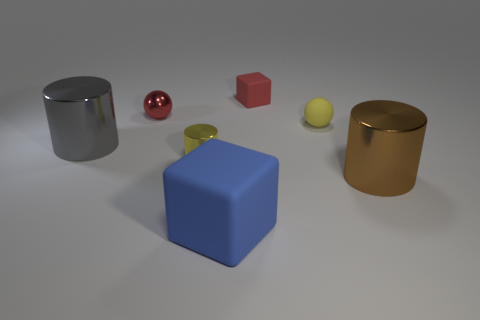Add 2 tiny yellow metal cylinders. How many objects exist? 9 Subtract all cylinders. How many objects are left? 4 Subtract all large gray objects. Subtract all red matte things. How many objects are left? 5 Add 2 shiny spheres. How many shiny spheres are left? 3 Add 3 tiny green spheres. How many tiny green spheres exist? 3 Subtract 0 blue cylinders. How many objects are left? 7 